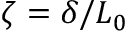Convert formula to latex. <formula><loc_0><loc_0><loc_500><loc_500>\zeta = \delta / L _ { 0 }</formula> 